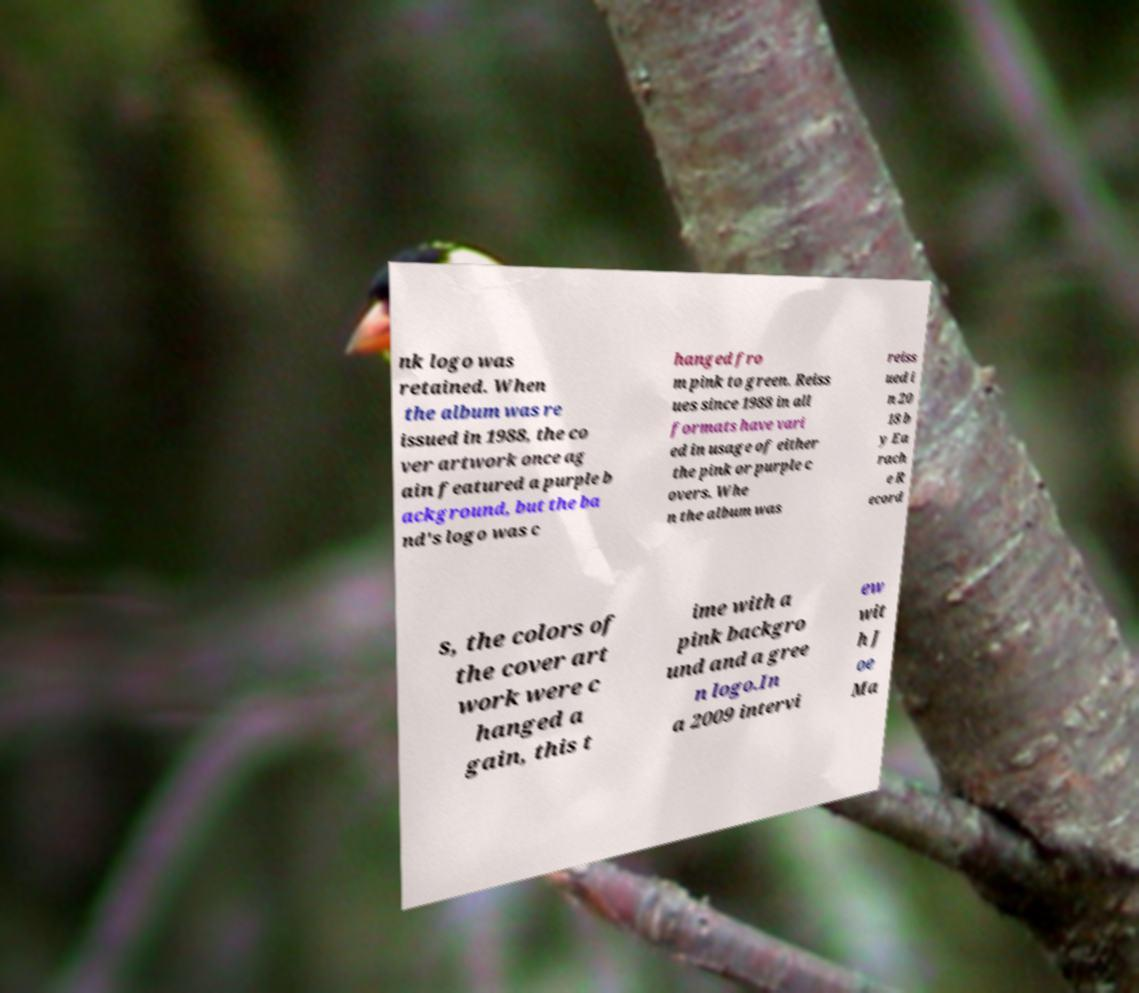Please read and relay the text visible in this image. What does it say? nk logo was retained. When the album was re issued in 1988, the co ver artwork once ag ain featured a purple b ackground, but the ba nd's logo was c hanged fro m pink to green. Reiss ues since 1988 in all formats have vari ed in usage of either the pink or purple c overs. Whe n the album was reiss ued i n 20 18 b y Ea rach e R ecord s, the colors of the cover art work were c hanged a gain, this t ime with a pink backgro und and a gree n logo.In a 2009 intervi ew wit h J oe Ma 